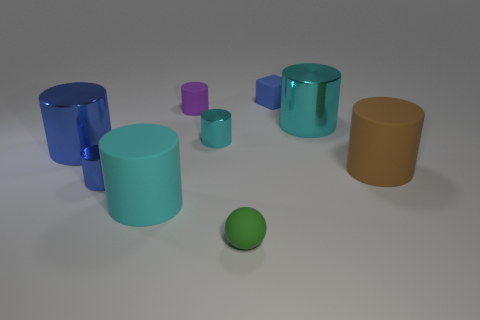What might be the context or setting for these objects? The objects are displayed against a plain background, suggesting a controlled setting like a studio or a 3D modeling environment. The lack of any wear or distinctive markings, along with their perfect geometric forms, imply the objects might be used for demonstration, perhaps in an educational context, or as part of a graphic design or 3D rendering project. 